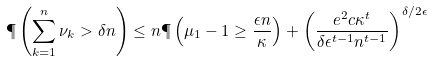<formula> <loc_0><loc_0><loc_500><loc_500>\P \left ( \sum _ { k = 1 } ^ { n } \nu _ { k } > \delta n \right ) \leq n \P \left ( \mu _ { 1 } - 1 \geq \frac { \epsilon n } { \kappa } \right ) + \left ( \frac { e ^ { 2 } c \kappa ^ { t } } { \delta \epsilon ^ { t - 1 } n ^ { t - 1 } } \right ) ^ { \delta / 2 \epsilon }</formula> 